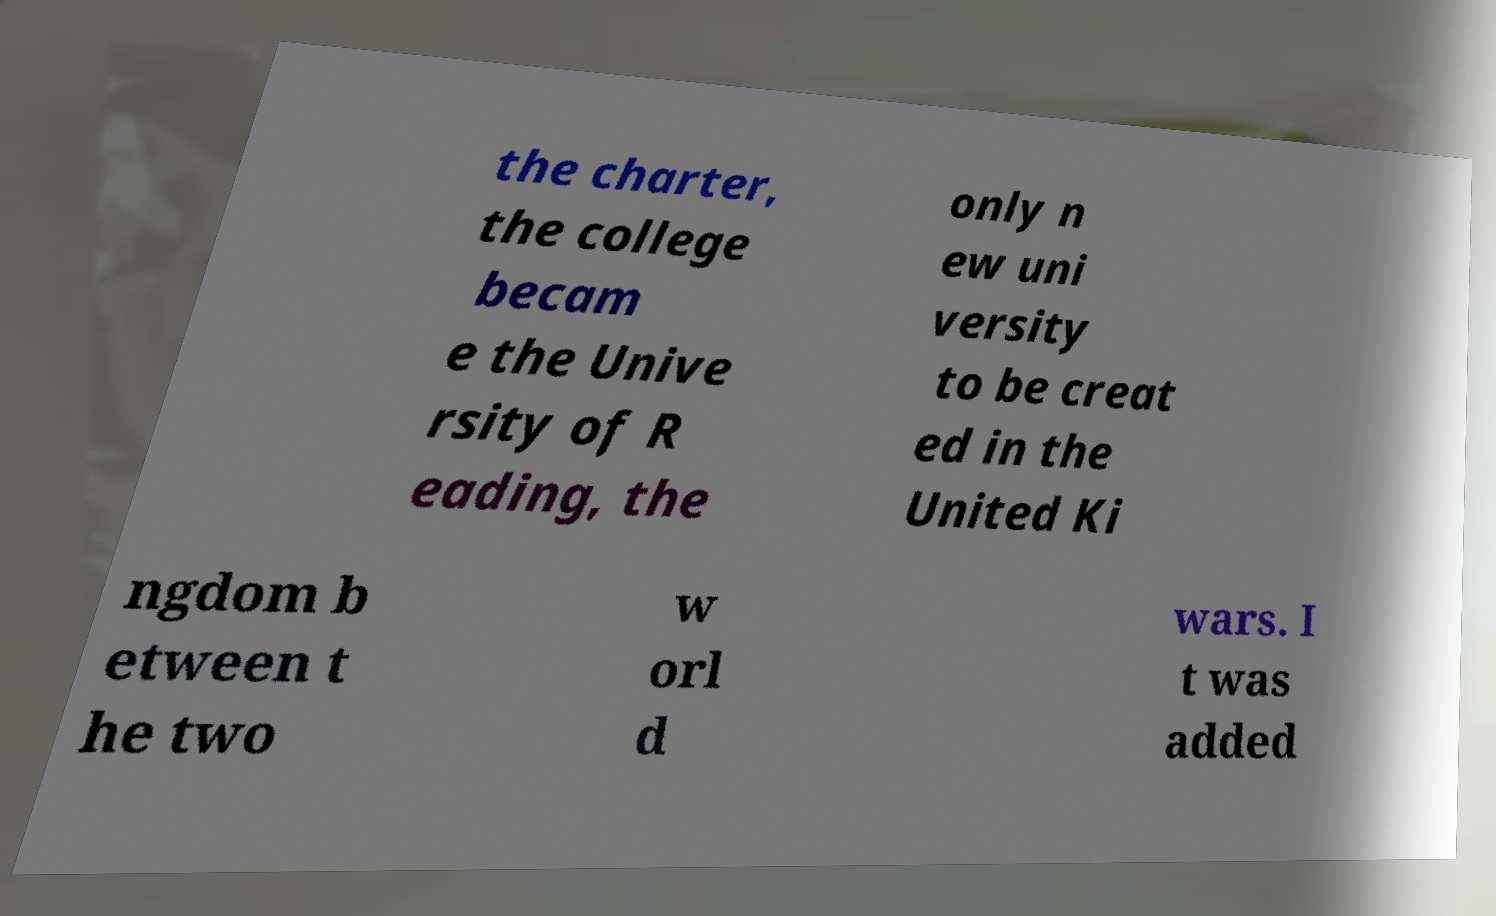For documentation purposes, I need the text within this image transcribed. Could you provide that? the charter, the college becam e the Unive rsity of R eading, the only n ew uni versity to be creat ed in the United Ki ngdom b etween t he two w orl d wars. I t was added 